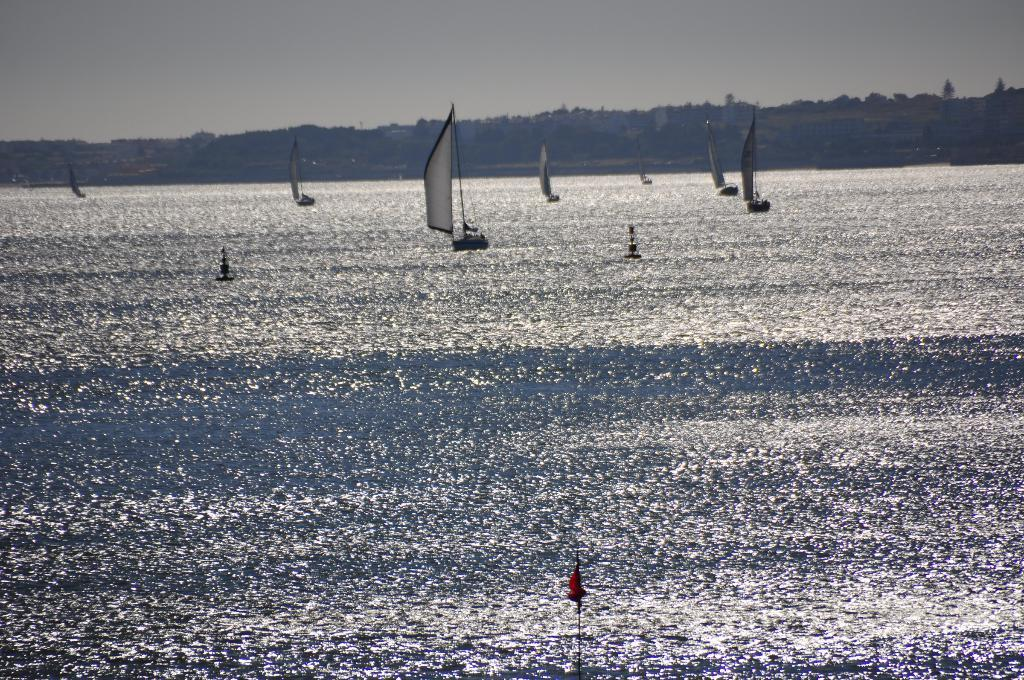What type of vehicles are present in the image? There are boats with flags in the image. Where are the boats located? The boats are on the water. What can be seen in the background of the image? There are hills and trees in the background of the image. What is visible at the top of the image? The sky is visible at the top of the image. What type of lead is being used to power the boats in the image? There is no indication of the boats being powered by lead in the image. In fact, boats are typically powered by engines or sails, not lead. 